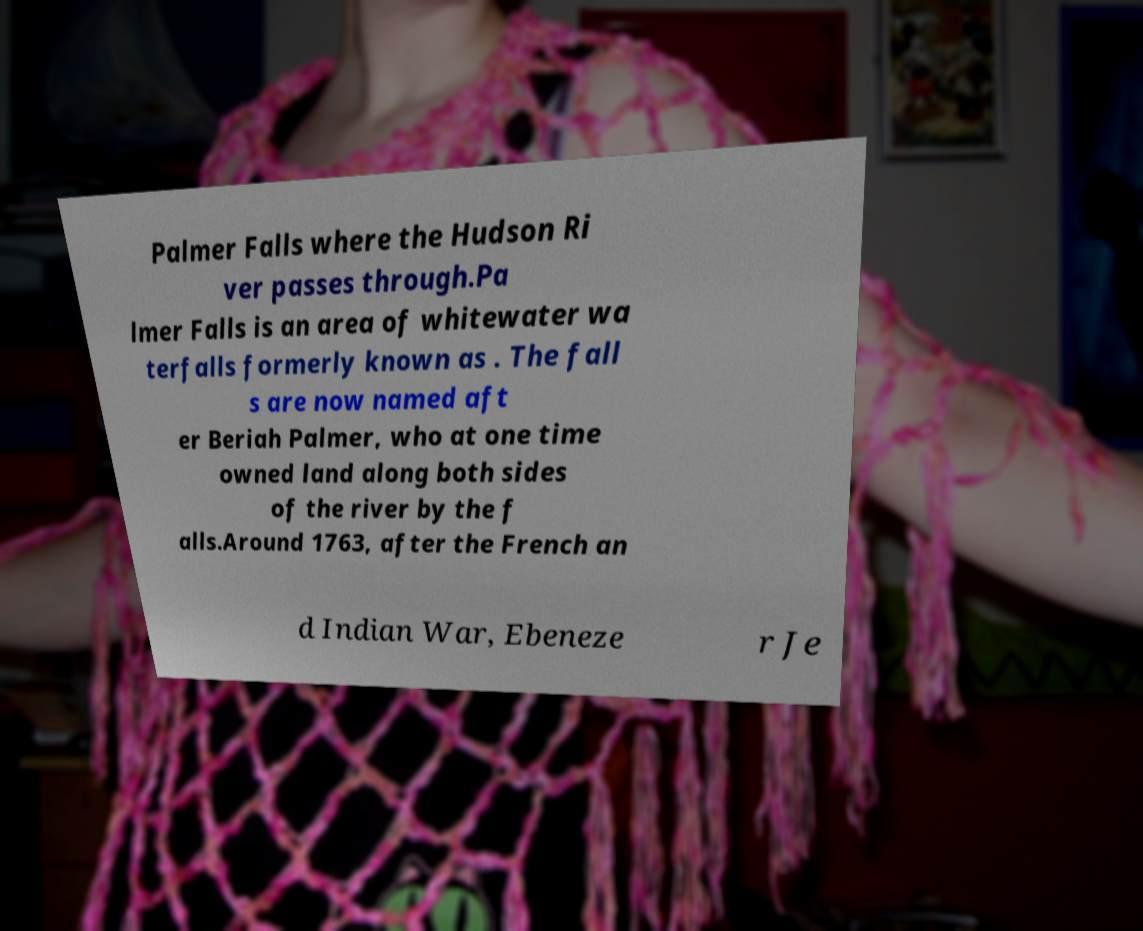Could you extract and type out the text from this image? Palmer Falls where the Hudson Ri ver passes through.Pa lmer Falls is an area of whitewater wa terfalls formerly known as . The fall s are now named aft er Beriah Palmer, who at one time owned land along both sides of the river by the f alls.Around 1763, after the French an d Indian War, Ebeneze r Je 